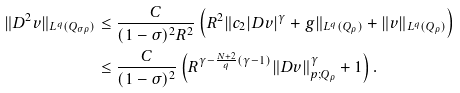<formula> <loc_0><loc_0><loc_500><loc_500>\| D ^ { 2 } v \| _ { L ^ { q } ( Q _ { \sigma \rho } ) } & \leq \frac { C } { ( 1 - \sigma ) ^ { 2 } R ^ { 2 } } \left ( R ^ { 2 } \| c _ { 2 } | D v | ^ { \gamma } + g \| _ { L ^ { q } ( Q _ { \rho } ) } + \| v \| _ { L ^ { q } ( Q _ { \rho } ) } \right ) \\ & \leq \frac { C } { ( 1 - \sigma ) ^ { 2 } } \left ( R ^ { \gamma - \frac { N + 2 } { q } ( \gamma - 1 ) } \| D v \| _ { p ; Q _ { \rho } } ^ { \gamma } + 1 \right ) .</formula> 